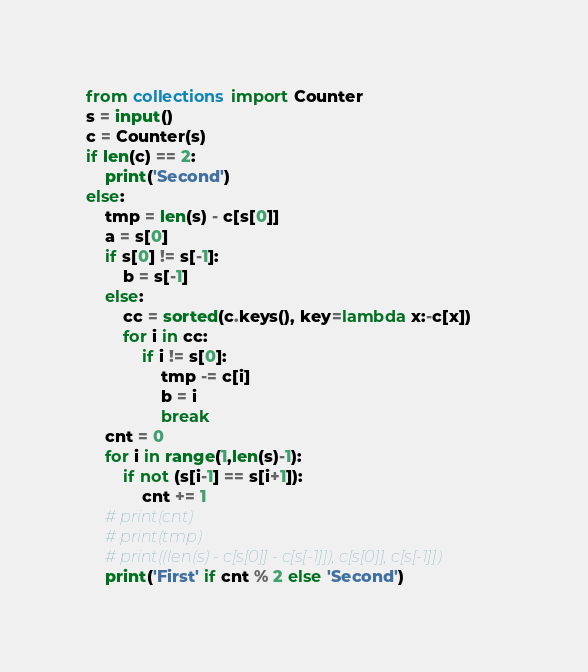Convert code to text. <code><loc_0><loc_0><loc_500><loc_500><_Python_>from collections import Counter
s = input()
c = Counter(s)
if len(c) == 2:
    print('Second')
else:
    tmp = len(s) - c[s[0]]
    a = s[0]
    if s[0] != s[-1]:
        b = s[-1]
    else:
        cc = sorted(c.keys(), key=lambda x:-c[x])
        for i in cc:
            if i != s[0]:
                tmp -= c[i]
                b = i
                break
    cnt = 0
    for i in range(1,len(s)-1):
        if not (s[i-1] == s[i+1]):
            cnt += 1
    # print(cnt)
    # print(tmp)
    # print((len(s) - c[s[0]] - c[s[-1]]), c[s[0]], c[s[-1]])
    print('First' if cnt % 2 else 'Second')
</code> 